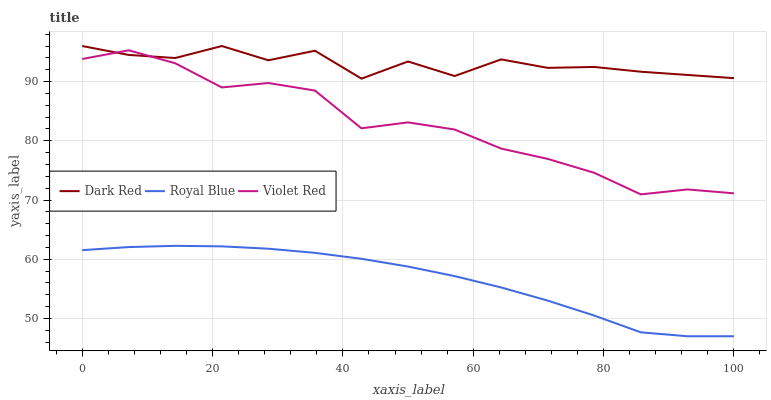Does Royal Blue have the minimum area under the curve?
Answer yes or no. Yes. Does Dark Red have the maximum area under the curve?
Answer yes or no. Yes. Does Violet Red have the minimum area under the curve?
Answer yes or no. No. Does Violet Red have the maximum area under the curve?
Answer yes or no. No. Is Royal Blue the smoothest?
Answer yes or no. Yes. Is Dark Red the roughest?
Answer yes or no. Yes. Is Violet Red the smoothest?
Answer yes or no. No. Is Violet Red the roughest?
Answer yes or no. No. Does Royal Blue have the lowest value?
Answer yes or no. Yes. Does Violet Red have the lowest value?
Answer yes or no. No. Does Dark Red have the highest value?
Answer yes or no. Yes. Does Violet Red have the highest value?
Answer yes or no. No. Is Royal Blue less than Violet Red?
Answer yes or no. Yes. Is Dark Red greater than Royal Blue?
Answer yes or no. Yes. Does Violet Red intersect Dark Red?
Answer yes or no. Yes. Is Violet Red less than Dark Red?
Answer yes or no. No. Is Violet Red greater than Dark Red?
Answer yes or no. No. Does Royal Blue intersect Violet Red?
Answer yes or no. No. 